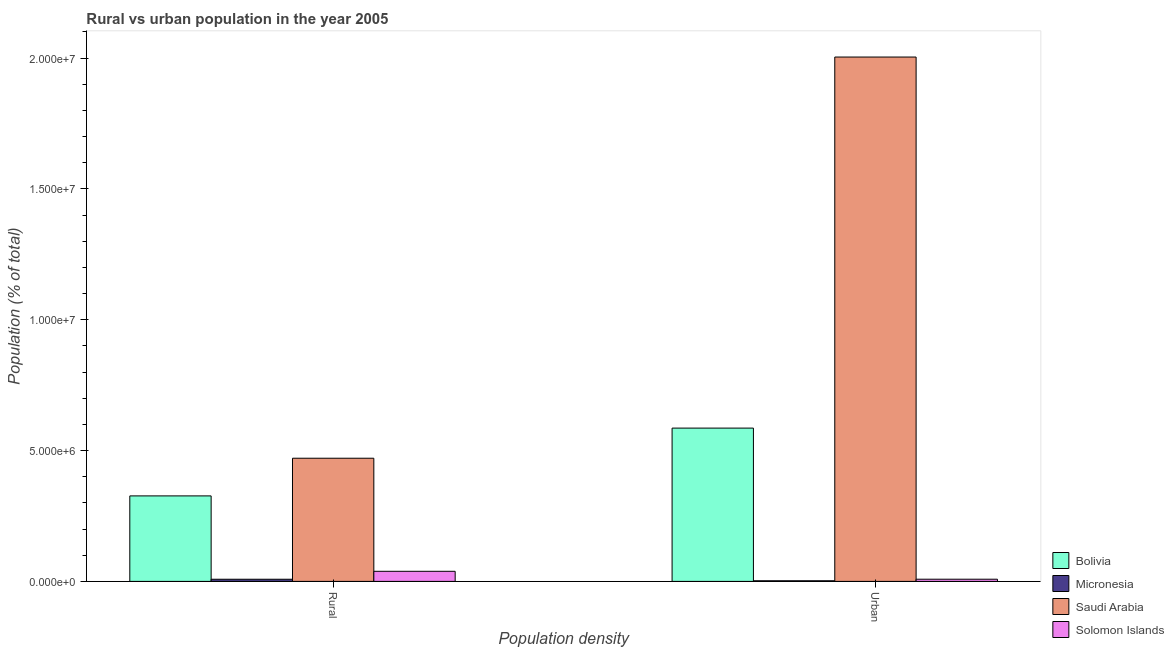How many different coloured bars are there?
Your response must be concise. 4. Are the number of bars per tick equal to the number of legend labels?
Offer a very short reply. Yes. How many bars are there on the 2nd tick from the right?
Offer a terse response. 4. What is the label of the 1st group of bars from the left?
Your response must be concise. Rural. What is the rural population density in Micronesia?
Keep it short and to the point. 8.25e+04. Across all countries, what is the maximum rural population density?
Your response must be concise. 4.71e+06. Across all countries, what is the minimum rural population density?
Your response must be concise. 8.25e+04. In which country was the urban population density maximum?
Your response must be concise. Saudi Arabia. In which country was the rural population density minimum?
Provide a succinct answer. Micronesia. What is the total urban population density in the graph?
Your response must be concise. 2.60e+07. What is the difference between the urban population density in Saudi Arabia and that in Solomon Islands?
Provide a short and direct response. 2.00e+07. What is the difference between the urban population density in Solomon Islands and the rural population density in Bolivia?
Your answer should be compact. -3.18e+06. What is the average urban population density per country?
Ensure brevity in your answer.  6.50e+06. What is the difference between the rural population density and urban population density in Bolivia?
Offer a terse response. -2.59e+06. What is the ratio of the urban population density in Solomon Islands to that in Bolivia?
Provide a succinct answer. 0.01. Is the urban population density in Bolivia less than that in Solomon Islands?
Your response must be concise. No. What does the 4th bar from the left in Rural represents?
Your answer should be compact. Solomon Islands. What does the 1st bar from the right in Urban represents?
Provide a succinct answer. Solomon Islands. How many bars are there?
Ensure brevity in your answer.  8. How many countries are there in the graph?
Keep it short and to the point. 4. Does the graph contain any zero values?
Your answer should be very brief. No. Does the graph contain grids?
Offer a terse response. No. Where does the legend appear in the graph?
Make the answer very short. Bottom right. How are the legend labels stacked?
Your answer should be compact. Vertical. What is the title of the graph?
Your answer should be very brief. Rural vs urban population in the year 2005. What is the label or title of the X-axis?
Offer a terse response. Population density. What is the label or title of the Y-axis?
Give a very brief answer. Population (% of total). What is the Population (% of total) in Bolivia in Rural?
Offer a very short reply. 3.27e+06. What is the Population (% of total) in Micronesia in Rural?
Offer a terse response. 8.25e+04. What is the Population (% of total) of Saudi Arabia in Rural?
Your response must be concise. 4.71e+06. What is the Population (% of total) in Solomon Islands in Rural?
Provide a succinct answer. 3.86e+05. What is the Population (% of total) of Bolivia in Urban?
Offer a very short reply. 5.86e+06. What is the Population (% of total) in Micronesia in Urban?
Make the answer very short. 2.37e+04. What is the Population (% of total) of Saudi Arabia in Urban?
Your response must be concise. 2.00e+07. What is the Population (% of total) in Solomon Islands in Urban?
Offer a terse response. 8.37e+04. Across all Population density, what is the maximum Population (% of total) of Bolivia?
Keep it short and to the point. 5.86e+06. Across all Population density, what is the maximum Population (% of total) of Micronesia?
Keep it short and to the point. 8.25e+04. Across all Population density, what is the maximum Population (% of total) of Saudi Arabia?
Offer a very short reply. 2.00e+07. Across all Population density, what is the maximum Population (% of total) of Solomon Islands?
Provide a succinct answer. 3.86e+05. Across all Population density, what is the minimum Population (% of total) of Bolivia?
Your response must be concise. 3.27e+06. Across all Population density, what is the minimum Population (% of total) of Micronesia?
Your answer should be compact. 2.37e+04. Across all Population density, what is the minimum Population (% of total) in Saudi Arabia?
Keep it short and to the point. 4.71e+06. Across all Population density, what is the minimum Population (% of total) of Solomon Islands?
Provide a succinct answer. 8.37e+04. What is the total Population (% of total) in Bolivia in the graph?
Offer a very short reply. 9.13e+06. What is the total Population (% of total) of Micronesia in the graph?
Provide a short and direct response. 1.06e+05. What is the total Population (% of total) of Saudi Arabia in the graph?
Offer a terse response. 2.47e+07. What is the total Population (% of total) of Solomon Islands in the graph?
Your answer should be compact. 4.69e+05. What is the difference between the Population (% of total) in Bolivia in Rural and that in Urban?
Keep it short and to the point. -2.59e+06. What is the difference between the Population (% of total) in Micronesia in Rural and that in Urban?
Your response must be concise. 5.88e+04. What is the difference between the Population (% of total) of Saudi Arabia in Rural and that in Urban?
Offer a very short reply. -1.53e+07. What is the difference between the Population (% of total) of Solomon Islands in Rural and that in Urban?
Ensure brevity in your answer.  3.02e+05. What is the difference between the Population (% of total) of Bolivia in Rural and the Population (% of total) of Micronesia in Urban?
Your answer should be compact. 3.24e+06. What is the difference between the Population (% of total) in Bolivia in Rural and the Population (% of total) in Saudi Arabia in Urban?
Provide a succinct answer. -1.68e+07. What is the difference between the Population (% of total) in Bolivia in Rural and the Population (% of total) in Solomon Islands in Urban?
Make the answer very short. 3.18e+06. What is the difference between the Population (% of total) in Micronesia in Rural and the Population (% of total) in Saudi Arabia in Urban?
Keep it short and to the point. -2.00e+07. What is the difference between the Population (% of total) in Micronesia in Rural and the Population (% of total) in Solomon Islands in Urban?
Give a very brief answer. -1203. What is the difference between the Population (% of total) in Saudi Arabia in Rural and the Population (% of total) in Solomon Islands in Urban?
Offer a terse response. 4.62e+06. What is the average Population (% of total) in Bolivia per Population density?
Offer a terse response. 4.56e+06. What is the average Population (% of total) in Micronesia per Population density?
Give a very brief answer. 5.31e+04. What is the average Population (% of total) in Saudi Arabia per Population density?
Offer a very short reply. 1.24e+07. What is the average Population (% of total) in Solomon Islands per Population density?
Provide a succinct answer. 2.35e+05. What is the difference between the Population (% of total) of Bolivia and Population (% of total) of Micronesia in Rural?
Your response must be concise. 3.18e+06. What is the difference between the Population (% of total) in Bolivia and Population (% of total) in Saudi Arabia in Rural?
Your answer should be very brief. -1.44e+06. What is the difference between the Population (% of total) in Bolivia and Population (% of total) in Solomon Islands in Rural?
Provide a succinct answer. 2.88e+06. What is the difference between the Population (% of total) in Micronesia and Population (% of total) in Saudi Arabia in Rural?
Make the answer very short. -4.62e+06. What is the difference between the Population (% of total) in Micronesia and Population (% of total) in Solomon Islands in Rural?
Make the answer very short. -3.03e+05. What is the difference between the Population (% of total) in Saudi Arabia and Population (% of total) in Solomon Islands in Rural?
Make the answer very short. 4.32e+06. What is the difference between the Population (% of total) in Bolivia and Population (% of total) in Micronesia in Urban?
Your response must be concise. 5.83e+06. What is the difference between the Population (% of total) of Bolivia and Population (% of total) of Saudi Arabia in Urban?
Your answer should be very brief. -1.42e+07. What is the difference between the Population (% of total) of Bolivia and Population (% of total) of Solomon Islands in Urban?
Ensure brevity in your answer.  5.77e+06. What is the difference between the Population (% of total) in Micronesia and Population (% of total) in Saudi Arabia in Urban?
Your answer should be compact. -2.00e+07. What is the difference between the Population (% of total) of Micronesia and Population (% of total) of Solomon Islands in Urban?
Your answer should be compact. -6.00e+04. What is the difference between the Population (% of total) in Saudi Arabia and Population (% of total) in Solomon Islands in Urban?
Give a very brief answer. 2.00e+07. What is the ratio of the Population (% of total) in Bolivia in Rural to that in Urban?
Offer a terse response. 0.56. What is the ratio of the Population (% of total) in Micronesia in Rural to that in Urban?
Your response must be concise. 3.48. What is the ratio of the Population (% of total) in Saudi Arabia in Rural to that in Urban?
Provide a short and direct response. 0.23. What is the ratio of the Population (% of total) of Solomon Islands in Rural to that in Urban?
Keep it short and to the point. 4.61. What is the difference between the highest and the second highest Population (% of total) of Bolivia?
Your answer should be very brief. 2.59e+06. What is the difference between the highest and the second highest Population (% of total) of Micronesia?
Keep it short and to the point. 5.88e+04. What is the difference between the highest and the second highest Population (% of total) in Saudi Arabia?
Your answer should be very brief. 1.53e+07. What is the difference between the highest and the second highest Population (% of total) of Solomon Islands?
Provide a succinct answer. 3.02e+05. What is the difference between the highest and the lowest Population (% of total) of Bolivia?
Keep it short and to the point. 2.59e+06. What is the difference between the highest and the lowest Population (% of total) of Micronesia?
Provide a short and direct response. 5.88e+04. What is the difference between the highest and the lowest Population (% of total) in Saudi Arabia?
Your answer should be very brief. 1.53e+07. What is the difference between the highest and the lowest Population (% of total) of Solomon Islands?
Keep it short and to the point. 3.02e+05. 